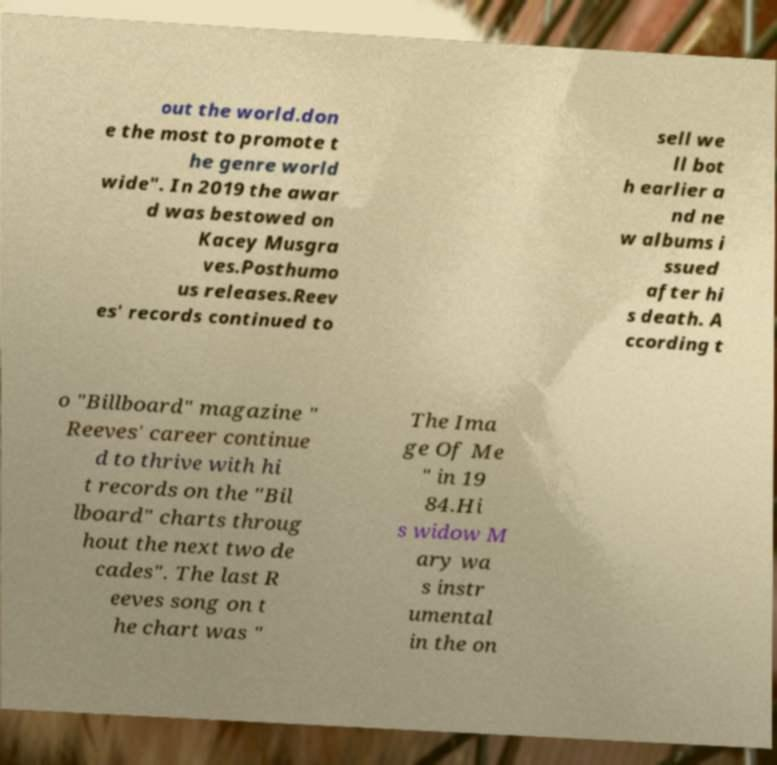I need the written content from this picture converted into text. Can you do that? out the world.don e the most to promote t he genre world wide". In 2019 the awar d was bestowed on Kacey Musgra ves.Posthumo us releases.Reev es' records continued to sell we ll bot h earlier a nd ne w albums i ssued after hi s death. A ccording t o "Billboard" magazine " Reeves' career continue d to thrive with hi t records on the "Bil lboard" charts throug hout the next two de cades". The last R eeves song on t he chart was " The Ima ge Of Me " in 19 84.Hi s widow M ary wa s instr umental in the on 